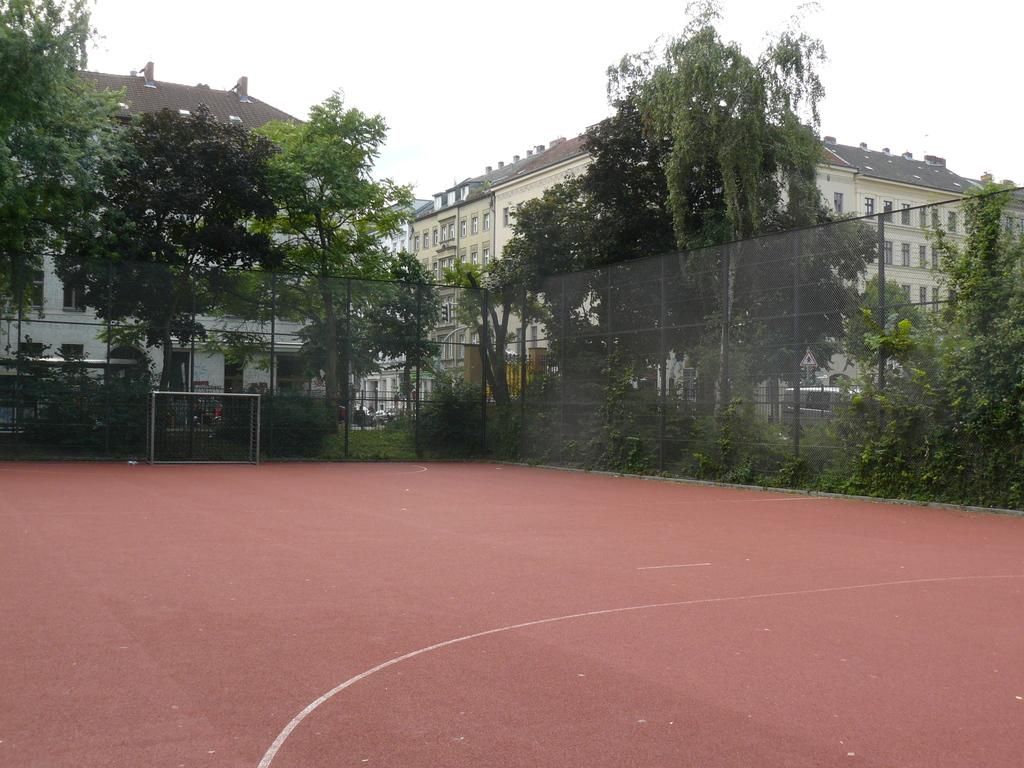What is located in the center of the image? There are buildings in the center of the image. What type of natural elements can be seen in the image? There are trees in the image. What objects are present in the image that might be used for support or signage? There are poles in the image. What object is present in the image that might be used for catching or holding items? There is a net in the image. What part of the image represents the ground? The ground is visible at the bottom of the image. What part of the image represents the sky? The sky is visible at the top of the image. How does the father interact with the buildings in the image? There is no father present in the image; it only features buildings, trees, poles, a net, the ground, and the sky. What is the size of the comparison between the trees and the buildings in the image? There is no comparison being made between the trees and the buildings in the image; they are simply two separate elements. 